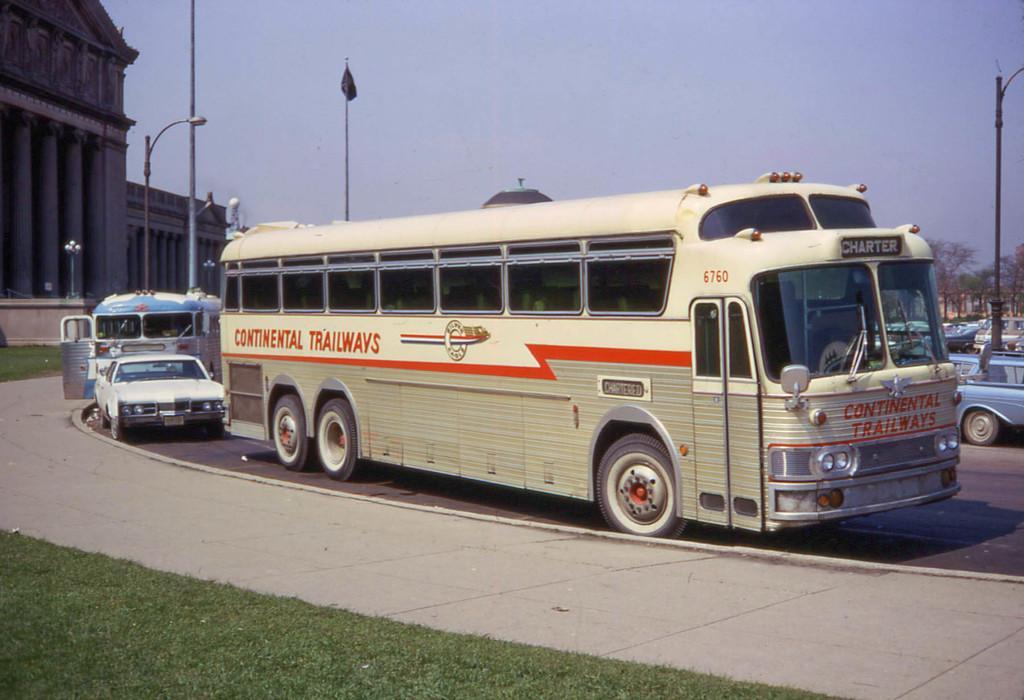Could you give a brief overview of what you see in this image? A bus is moving on the road, left side there are monuments. At the top it is the sky. 